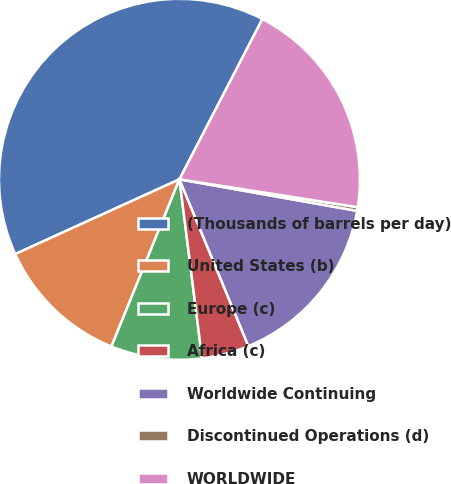Convert chart. <chart><loc_0><loc_0><loc_500><loc_500><pie_chart><fcel>(Thousands of barrels per day)<fcel>United States (b)<fcel>Europe (c)<fcel>Africa (c)<fcel>Worldwide Continuing<fcel>Discontinued Operations (d)<fcel>WORLDWIDE<nl><fcel>39.4%<fcel>12.05%<fcel>8.15%<fcel>4.24%<fcel>15.96%<fcel>0.33%<fcel>19.87%<nl></chart> 